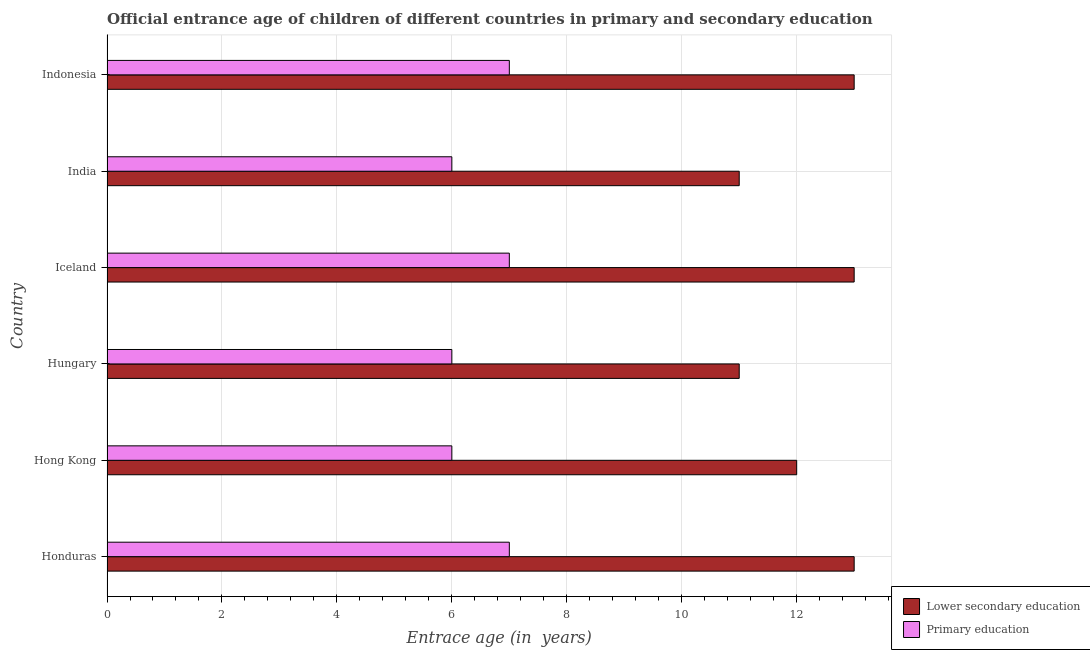Are the number of bars on each tick of the Y-axis equal?
Your answer should be compact. Yes. How many bars are there on the 6th tick from the top?
Your answer should be compact. 2. What is the label of the 5th group of bars from the top?
Offer a very short reply. Hong Kong. What is the entrance age of chiildren in primary education in Hong Kong?
Offer a very short reply. 6. Across all countries, what is the maximum entrance age of children in lower secondary education?
Offer a very short reply. 13. Across all countries, what is the minimum entrance age of children in lower secondary education?
Your answer should be very brief. 11. In which country was the entrance age of children in lower secondary education maximum?
Ensure brevity in your answer.  Honduras. In which country was the entrance age of chiildren in primary education minimum?
Provide a succinct answer. Hong Kong. What is the total entrance age of children in lower secondary education in the graph?
Make the answer very short. 73. What is the difference between the entrance age of chiildren in primary education in Honduras and that in Hong Kong?
Provide a succinct answer. 1. What is the difference between the entrance age of children in lower secondary education in Indonesia and the entrance age of chiildren in primary education in Iceland?
Your answer should be compact. 6. What is the average entrance age of chiildren in primary education per country?
Ensure brevity in your answer.  6.5. What is the difference between the entrance age of chiildren in primary education and entrance age of children in lower secondary education in Indonesia?
Provide a short and direct response. -6. In how many countries, is the entrance age of chiildren in primary education greater than 11.2 years?
Offer a terse response. 0. What is the ratio of the entrance age of children in lower secondary education in Hungary to that in India?
Make the answer very short. 1. Is the entrance age of children in lower secondary education in Honduras less than that in Hong Kong?
Offer a very short reply. No. Is the difference between the entrance age of children in lower secondary education in Hong Kong and Iceland greater than the difference between the entrance age of chiildren in primary education in Hong Kong and Iceland?
Provide a succinct answer. No. What is the difference between the highest and the lowest entrance age of chiildren in primary education?
Give a very brief answer. 1. Is the sum of the entrance age of chiildren in primary education in Hungary and Iceland greater than the maximum entrance age of children in lower secondary education across all countries?
Offer a terse response. No. What does the 1st bar from the top in Indonesia represents?
Your response must be concise. Primary education. What does the 1st bar from the bottom in Iceland represents?
Ensure brevity in your answer.  Lower secondary education. How many bars are there?
Offer a very short reply. 12. Are all the bars in the graph horizontal?
Provide a short and direct response. Yes. Are the values on the major ticks of X-axis written in scientific E-notation?
Offer a terse response. No. Does the graph contain grids?
Ensure brevity in your answer.  Yes. How are the legend labels stacked?
Your answer should be very brief. Vertical. What is the title of the graph?
Offer a very short reply. Official entrance age of children of different countries in primary and secondary education. What is the label or title of the X-axis?
Your answer should be compact. Entrace age (in  years). What is the label or title of the Y-axis?
Give a very brief answer. Country. What is the Entrace age (in  years) in Lower secondary education in Honduras?
Provide a succinct answer. 13. What is the Entrace age (in  years) of Primary education in Honduras?
Your answer should be very brief. 7. What is the Entrace age (in  years) in Lower secondary education in Hong Kong?
Your answer should be very brief. 12. What is the Entrace age (in  years) in Primary education in Hong Kong?
Offer a very short reply. 6. What is the Entrace age (in  years) in Lower secondary education in Hungary?
Your answer should be very brief. 11. What is the Entrace age (in  years) in Primary education in Hungary?
Provide a succinct answer. 6. What is the Entrace age (in  years) of Lower secondary education in India?
Provide a short and direct response. 11. Across all countries, what is the maximum Entrace age (in  years) of Primary education?
Provide a short and direct response. 7. Across all countries, what is the minimum Entrace age (in  years) in Lower secondary education?
Your answer should be compact. 11. What is the total Entrace age (in  years) in Primary education in the graph?
Provide a succinct answer. 39. What is the difference between the Entrace age (in  years) in Lower secondary education in Honduras and that in Hong Kong?
Offer a very short reply. 1. What is the difference between the Entrace age (in  years) in Lower secondary education in Honduras and that in Hungary?
Your answer should be very brief. 2. What is the difference between the Entrace age (in  years) in Primary education in Honduras and that in Hungary?
Offer a very short reply. 1. What is the difference between the Entrace age (in  years) of Lower secondary education in Honduras and that in Iceland?
Make the answer very short. 0. What is the difference between the Entrace age (in  years) of Primary education in Honduras and that in Iceland?
Offer a terse response. 0. What is the difference between the Entrace age (in  years) of Lower secondary education in Honduras and that in India?
Provide a short and direct response. 2. What is the difference between the Entrace age (in  years) in Lower secondary education in Honduras and that in Indonesia?
Provide a succinct answer. 0. What is the difference between the Entrace age (in  years) in Primary education in Hong Kong and that in Hungary?
Offer a very short reply. 0. What is the difference between the Entrace age (in  years) of Primary education in Hong Kong and that in Iceland?
Provide a succinct answer. -1. What is the difference between the Entrace age (in  years) in Lower secondary education in Hong Kong and that in India?
Make the answer very short. 1. What is the difference between the Entrace age (in  years) in Lower secondary education in Hong Kong and that in Indonesia?
Provide a succinct answer. -1. What is the difference between the Entrace age (in  years) of Lower secondary education in Hungary and that in Iceland?
Your answer should be compact. -2. What is the difference between the Entrace age (in  years) in Lower secondary education in Hungary and that in India?
Ensure brevity in your answer.  0. What is the difference between the Entrace age (in  years) in Lower secondary education in Hungary and that in Indonesia?
Offer a very short reply. -2. What is the difference between the Entrace age (in  years) in Primary education in Hungary and that in Indonesia?
Your answer should be compact. -1. What is the difference between the Entrace age (in  years) in Primary education in Iceland and that in India?
Give a very brief answer. 1. What is the difference between the Entrace age (in  years) in Lower secondary education in Iceland and that in Indonesia?
Offer a very short reply. 0. What is the difference between the Entrace age (in  years) of Lower secondary education in Honduras and the Entrace age (in  years) of Primary education in Hong Kong?
Offer a terse response. 7. What is the difference between the Entrace age (in  years) in Lower secondary education in Honduras and the Entrace age (in  years) in Primary education in India?
Your answer should be compact. 7. What is the difference between the Entrace age (in  years) of Lower secondary education in Hong Kong and the Entrace age (in  years) of Primary education in Hungary?
Offer a very short reply. 6. What is the difference between the Entrace age (in  years) of Lower secondary education in Hong Kong and the Entrace age (in  years) of Primary education in India?
Offer a very short reply. 6. What is the difference between the Entrace age (in  years) in Lower secondary education in Hungary and the Entrace age (in  years) in Primary education in India?
Offer a terse response. 5. What is the difference between the Entrace age (in  years) in Lower secondary education in Iceland and the Entrace age (in  years) in Primary education in India?
Keep it short and to the point. 7. What is the average Entrace age (in  years) in Lower secondary education per country?
Your answer should be very brief. 12.17. What is the difference between the Entrace age (in  years) of Lower secondary education and Entrace age (in  years) of Primary education in Iceland?
Offer a very short reply. 6. What is the difference between the Entrace age (in  years) of Lower secondary education and Entrace age (in  years) of Primary education in Indonesia?
Provide a short and direct response. 6. What is the ratio of the Entrace age (in  years) in Primary education in Honduras to that in Hong Kong?
Offer a very short reply. 1.17. What is the ratio of the Entrace age (in  years) in Lower secondary education in Honduras to that in Hungary?
Provide a short and direct response. 1.18. What is the ratio of the Entrace age (in  years) in Lower secondary education in Honduras to that in Iceland?
Ensure brevity in your answer.  1. What is the ratio of the Entrace age (in  years) of Lower secondary education in Honduras to that in India?
Offer a terse response. 1.18. What is the ratio of the Entrace age (in  years) in Lower secondary education in Hong Kong to that in Hungary?
Your answer should be very brief. 1.09. What is the ratio of the Entrace age (in  years) in Primary education in Hong Kong to that in India?
Your answer should be compact. 1. What is the ratio of the Entrace age (in  years) of Lower secondary education in Hong Kong to that in Indonesia?
Give a very brief answer. 0.92. What is the ratio of the Entrace age (in  years) of Lower secondary education in Hungary to that in Iceland?
Give a very brief answer. 0.85. What is the ratio of the Entrace age (in  years) of Lower secondary education in Hungary to that in Indonesia?
Provide a short and direct response. 0.85. What is the ratio of the Entrace age (in  years) of Lower secondary education in Iceland to that in India?
Keep it short and to the point. 1.18. What is the ratio of the Entrace age (in  years) in Primary education in Iceland to that in India?
Keep it short and to the point. 1.17. What is the ratio of the Entrace age (in  years) of Lower secondary education in Iceland to that in Indonesia?
Your response must be concise. 1. What is the ratio of the Entrace age (in  years) in Lower secondary education in India to that in Indonesia?
Your response must be concise. 0.85. What is the difference between the highest and the second highest Entrace age (in  years) of Lower secondary education?
Provide a succinct answer. 0. What is the difference between the highest and the second highest Entrace age (in  years) of Primary education?
Your answer should be very brief. 0. What is the difference between the highest and the lowest Entrace age (in  years) in Lower secondary education?
Make the answer very short. 2. 